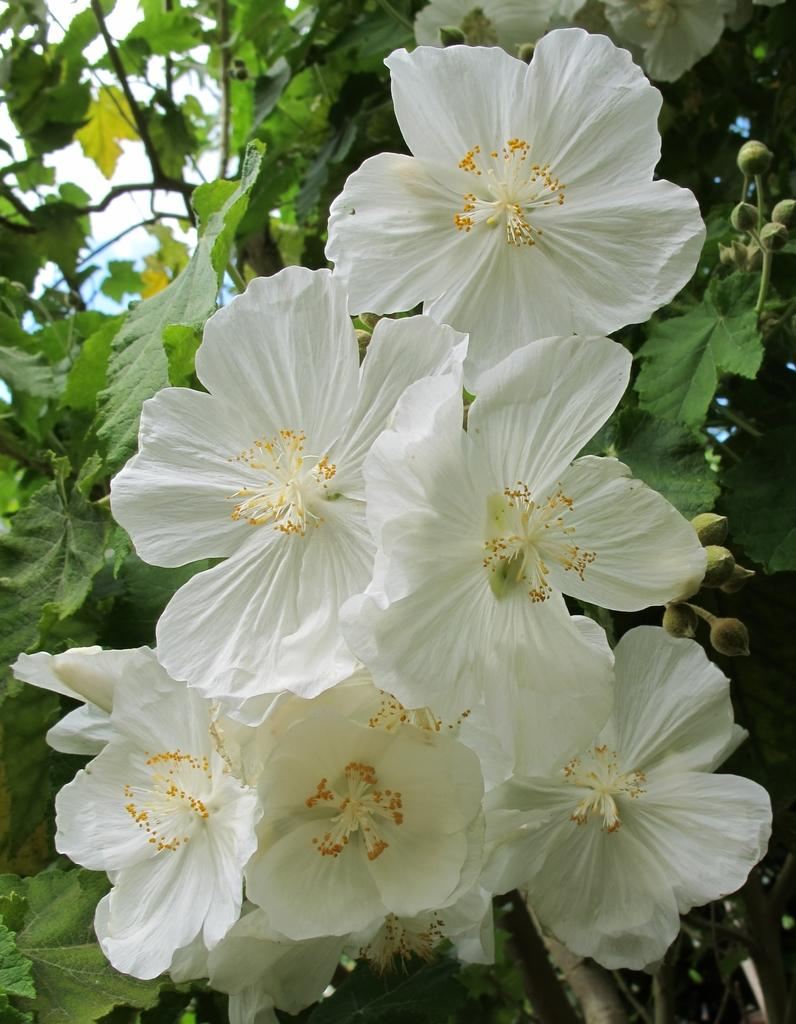What type of living organism can be seen in the image? There is a plant in the image. What stage of growth are the flowers on the plant in? The plant has buds, which means the flowers are not yet fully bloomed. What color are the flowers on the plant? The plant has white color flowers. What can be seen in the background of the image? There is sky visible in the background of the image. Can you see a giraffe wearing a skirt in the image? No, there is no giraffe or skirt present in the image. The image features a plant with white flowers and buds, and a sky visible in the background. 